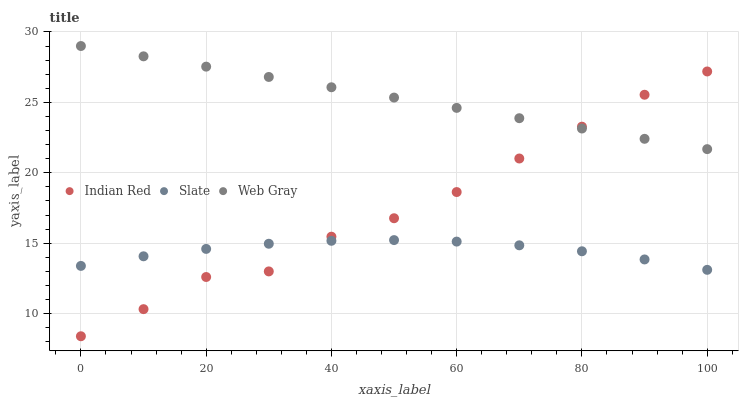Does Slate have the minimum area under the curve?
Answer yes or no. Yes. Does Web Gray have the maximum area under the curve?
Answer yes or no. Yes. Does Indian Red have the minimum area under the curve?
Answer yes or no. No. Does Indian Red have the maximum area under the curve?
Answer yes or no. No. Is Web Gray the smoothest?
Answer yes or no. Yes. Is Indian Red the roughest?
Answer yes or no. Yes. Is Indian Red the smoothest?
Answer yes or no. No. Is Web Gray the roughest?
Answer yes or no. No. Does Indian Red have the lowest value?
Answer yes or no. Yes. Does Web Gray have the lowest value?
Answer yes or no. No. Does Web Gray have the highest value?
Answer yes or no. Yes. Does Indian Red have the highest value?
Answer yes or no. No. Is Slate less than Web Gray?
Answer yes or no. Yes. Is Web Gray greater than Slate?
Answer yes or no. Yes. Does Slate intersect Indian Red?
Answer yes or no. Yes. Is Slate less than Indian Red?
Answer yes or no. No. Is Slate greater than Indian Red?
Answer yes or no. No. Does Slate intersect Web Gray?
Answer yes or no. No. 